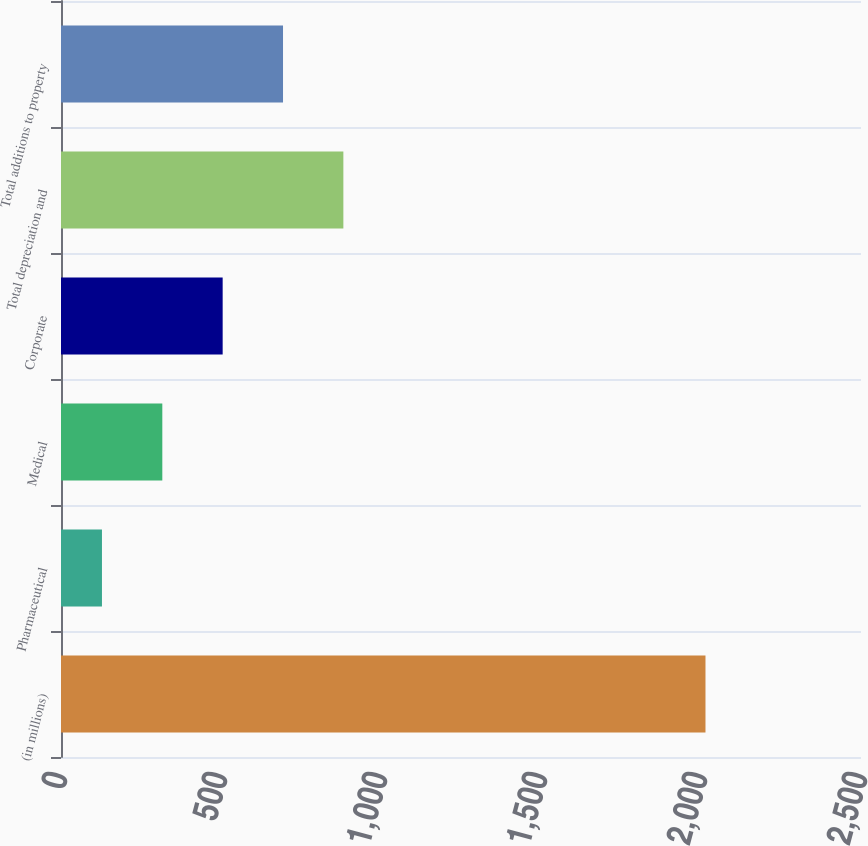<chart> <loc_0><loc_0><loc_500><loc_500><bar_chart><fcel>(in millions)<fcel>Pharmaceutical<fcel>Medical<fcel>Corporate<fcel>Total depreciation and<fcel>Total additions to property<nl><fcel>2014<fcel>128<fcel>316.6<fcel>505.2<fcel>882.4<fcel>693.8<nl></chart> 